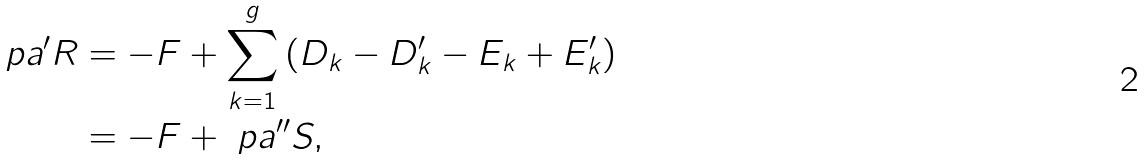Convert formula to latex. <formula><loc_0><loc_0><loc_500><loc_500>\ p a ^ { \prime } R & = - F + \sum _ { k = 1 } ^ { g } \left ( D _ { k } - D _ { k } ^ { \prime } - E _ { k } + E _ { k } ^ { \prime } \right ) \\ & = - F + \ p a ^ { \prime \prime } S ,</formula> 